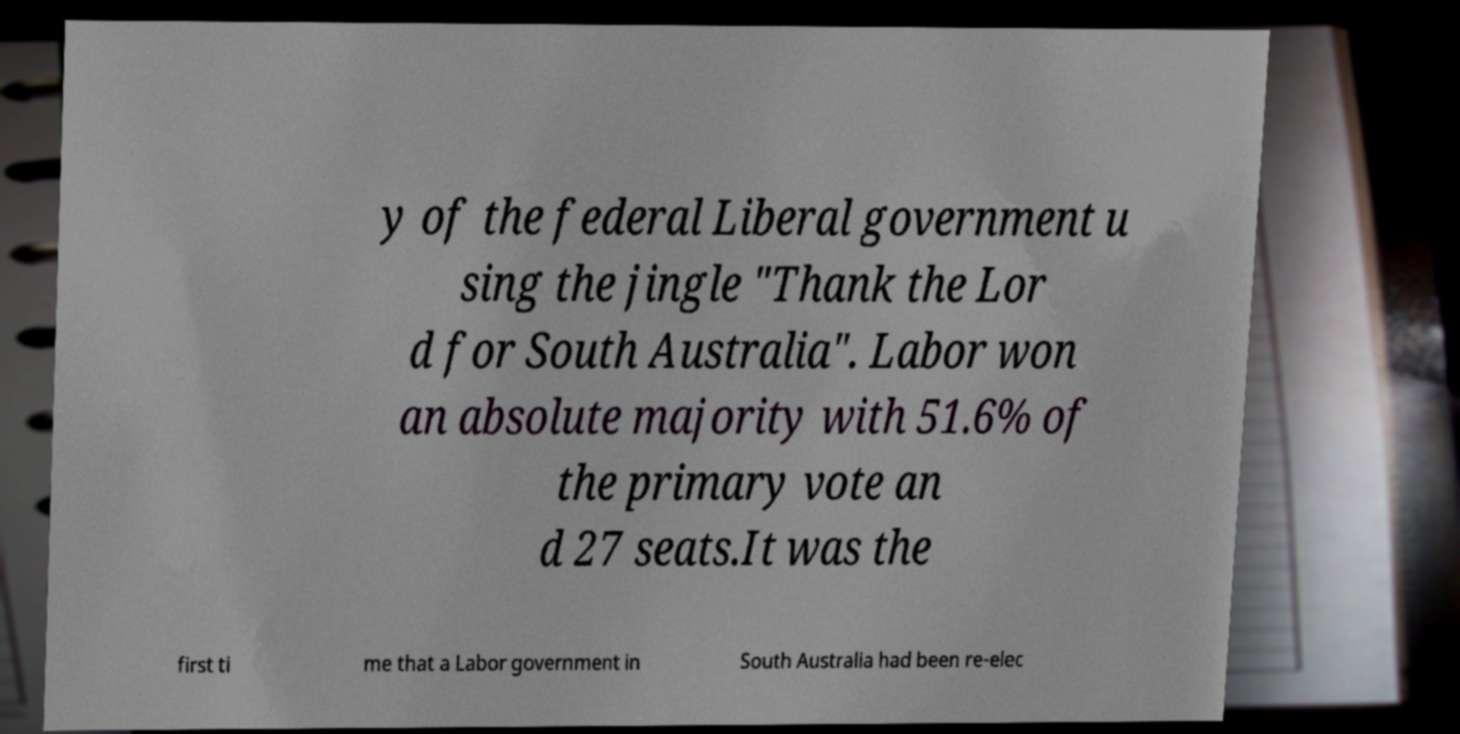Could you assist in decoding the text presented in this image and type it out clearly? y of the federal Liberal government u sing the jingle "Thank the Lor d for South Australia". Labor won an absolute majority with 51.6% of the primary vote an d 27 seats.It was the first ti me that a Labor government in South Australia had been re-elec 